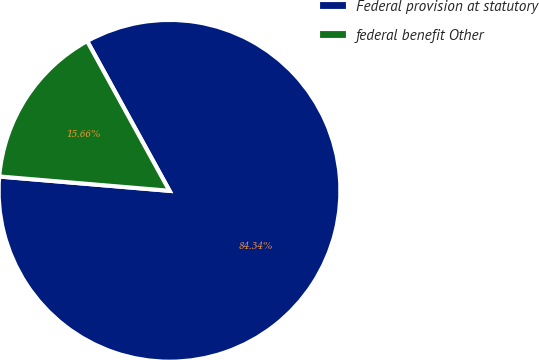Convert chart. <chart><loc_0><loc_0><loc_500><loc_500><pie_chart><fcel>Federal provision at statutory<fcel>federal benefit Other<nl><fcel>84.34%<fcel>15.66%<nl></chart> 